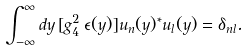Convert formula to latex. <formula><loc_0><loc_0><loc_500><loc_500>\int _ { - \infty } ^ { \infty } d y \, [ g _ { 4 } ^ { 2 } \, \epsilon ( y ) ] u _ { n } ( y ) ^ { * } u _ { l } ( y ) = \delta _ { n l } .</formula> 